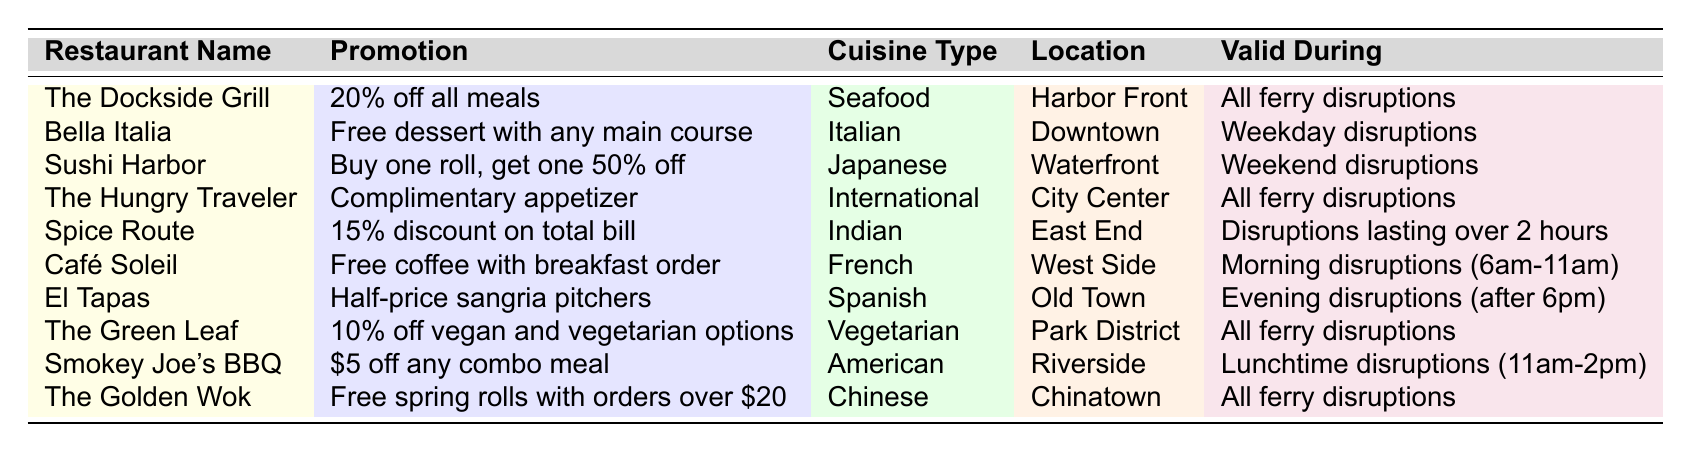What promotion does The Dockside Grill offer? The table states that The Dockside Grill offers "20% off all meals."
Answer: 20% off all meals Which restaurant offers a complimentary appetizer? According to the table, The Hungry Traveler offers a complimentary appetizer.
Answer: The Hungry Traveler How many restaurants have promotions valid during all ferry disruptions? By examining the table, there are four restaurants (The Dockside Grill, The Hungry Traveler, The Green Leaf, and The Golden Wok) that offer promotions valid during all ferry disruptions.
Answer: 4 Does Spice Route offer a promotion valid during weekday disruptions? The table shows that Spice Route's promotion is valid for disruptions lasting over 2 hours, not specifically for weekdays, so the answer is no.
Answer: No Which restaurant provides a discount specifically for lunchtime disruptions? The table indicates that Smokey Joe's BBQ offers a discount of $5 off any combo meal during lunchtime disruptions (11am-2pm).
Answer: Smokey Joe's BBQ What is the promotion offered by Bella Italia? According to the table, Bella Italia offers a free dessert with any main course.
Answer: Free dessert with any main course Is there a restaurant that has a promotion for morning disruptions? If so, which one? Yes, Café Soleil has a promotion for morning disruptions, offering free coffee with breakfast orders from 6 am to 11 am.
Answer: Café Soleil How does the promotion of Sushi Harbor compare to that of El Tapas? Sushi Harbor offers "Buy one roll, get one 50% off" while El Tapas offers "Half-price sangria pitchers," making Sushi Harbor's promotion focused on sushi rolls and El Tapas's focused on drinks.
Answer: Sushi Harbor offers a sushi promotion, El Tapas offers a drink promotion Which cuisine types have promotions valid during disruptions lasting over 2 hours? The table specifies that Spice Route (Indian cuisine) is valid for disruptions over 2 hours; the only restaurant fitting this criterion is Spice Route for Indian cuisine.
Answer: Indian (Spice Route) If someone wanted a vegan option, which restaurant would they choose based on the table? The table shows that The Green Leaf offers a 10% discount on vegan and vegetarian options, so that would be the best choice for someone looking for vegan options.
Answer: The Green Leaf 